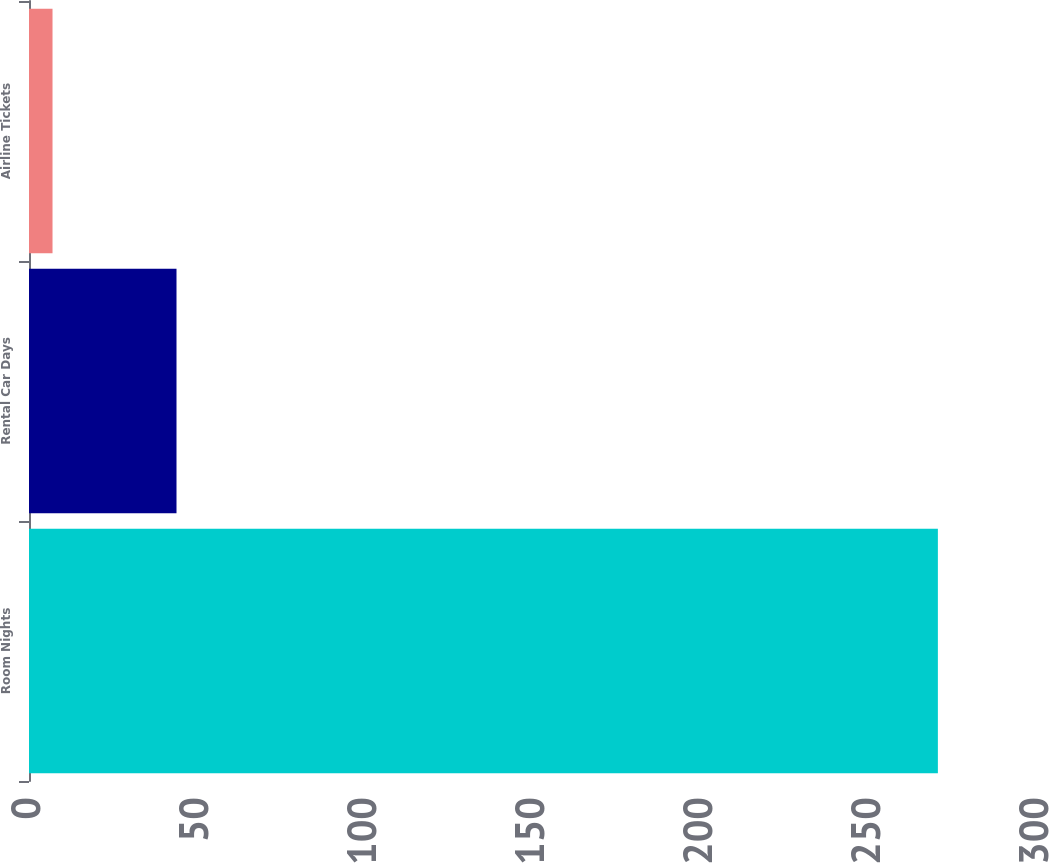Convert chart. <chart><loc_0><loc_0><loc_500><loc_500><bar_chart><fcel>Room Nights<fcel>Rental Car Days<fcel>Airline Tickets<nl><fcel>270.5<fcel>43.9<fcel>7<nl></chart> 